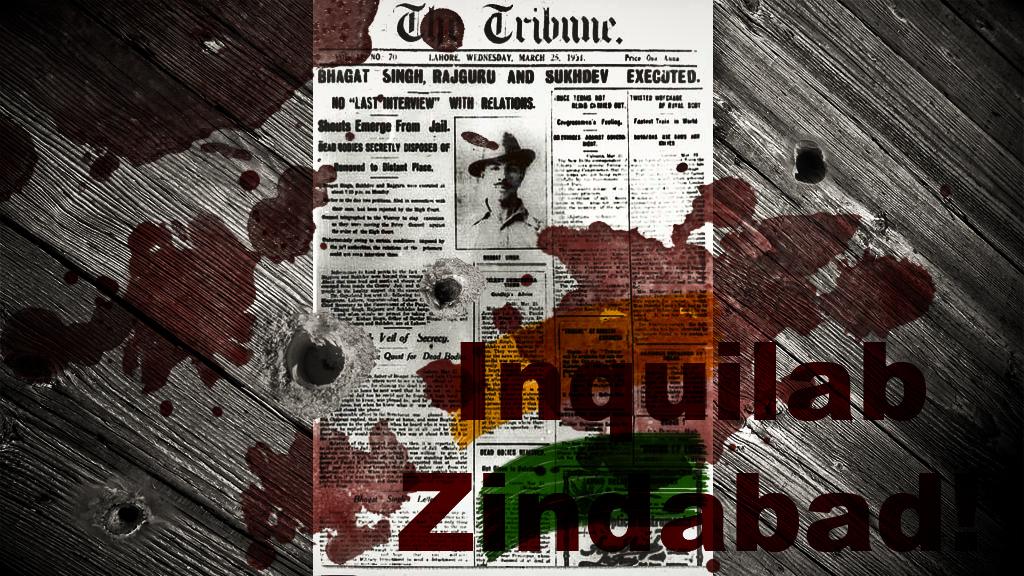What is the name of the publisher?
Your response must be concise. The tribune. 